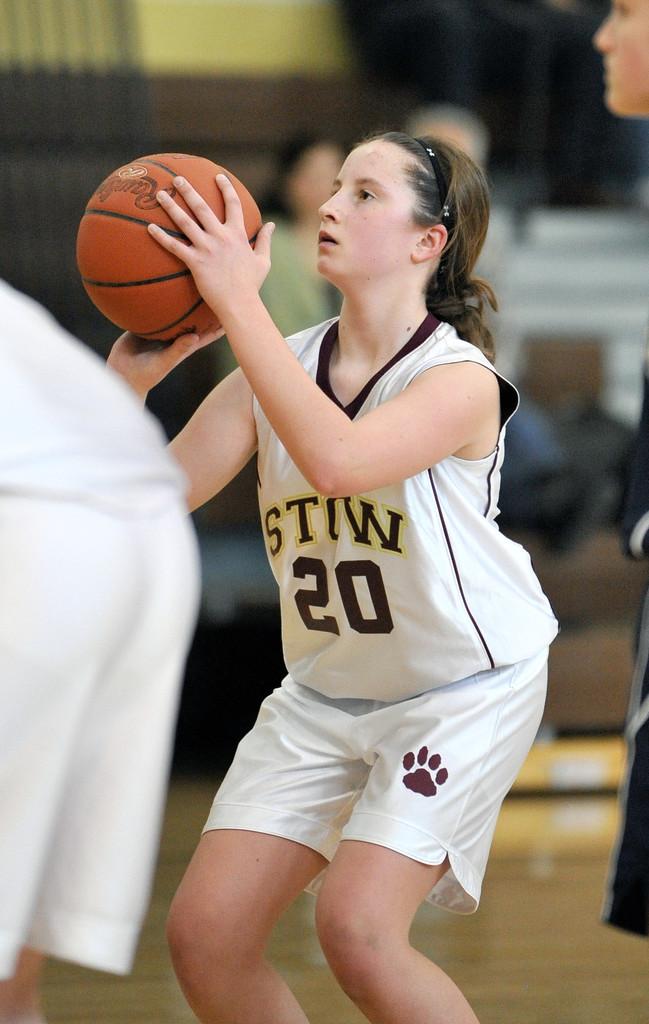What number is the basketball player?
Your response must be concise. 20. What team is this?
Offer a very short reply. Stiw. 